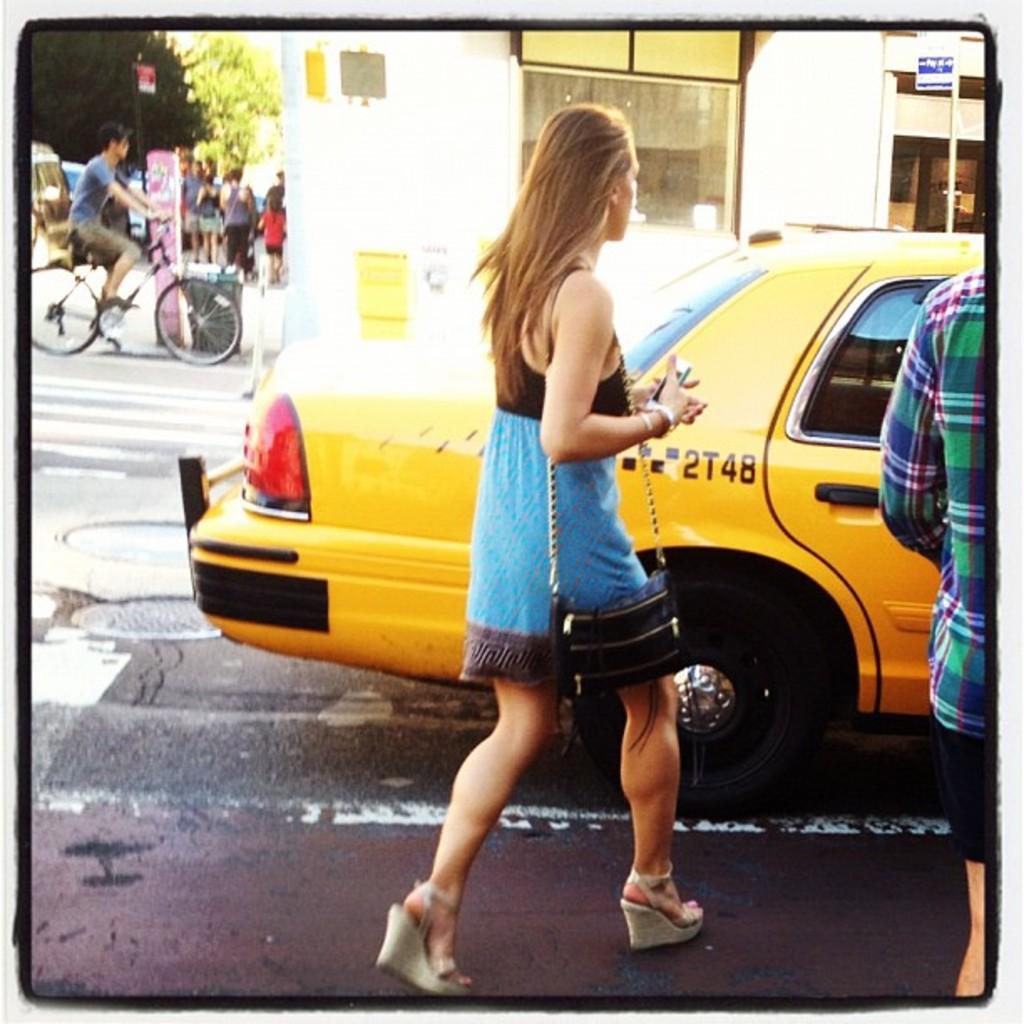What is this taxi's identification number?
Ensure brevity in your answer.  2t48. 